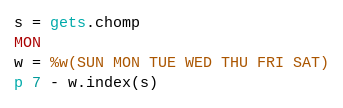Convert code to text. <code><loc_0><loc_0><loc_500><loc_500><_Ruby_>s = gets.chomp
MON
w = %w(SUN MON TUE WED THU FRI SAT)
p 7 - w.index(s)</code> 